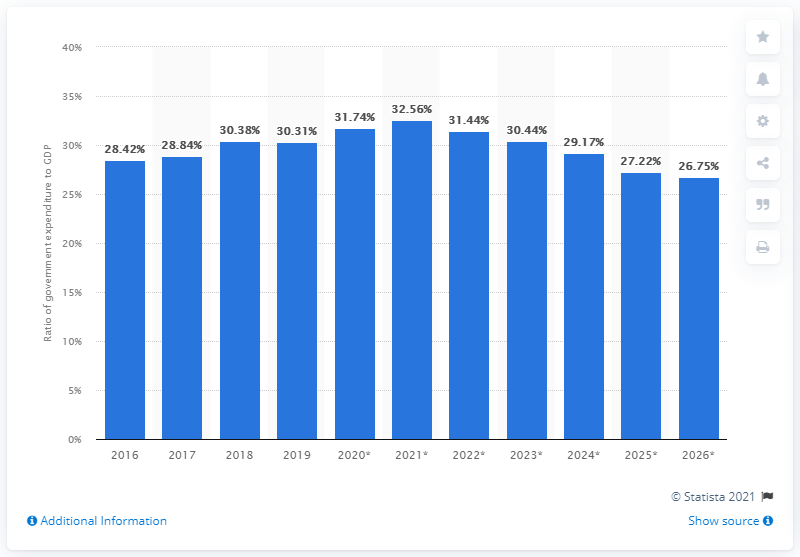Mention a couple of crucial points in this snapshot. In 2019, government expenditure in Jordan accounted for approximately 30.44 percent of the country's Gross Domestic Product (GDP). 